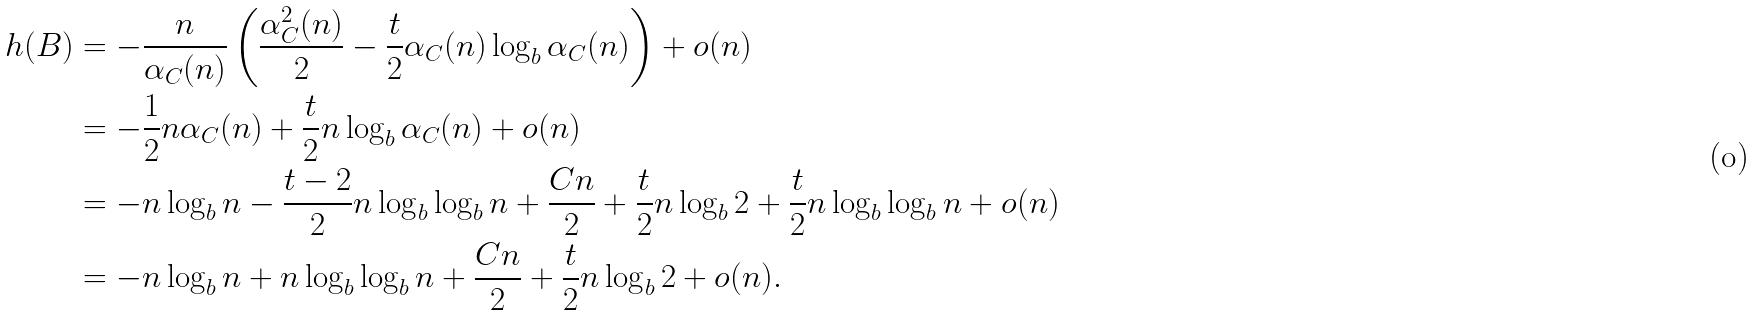<formula> <loc_0><loc_0><loc_500><loc_500>h ( B ) & = - \frac { n } { \alpha _ { C } ( n ) } \left ( \frac { \alpha _ { C } ^ { 2 } ( n ) } { 2 } - \frac { t } { 2 } \alpha _ { C } ( n ) \log _ { b } \alpha _ { C } ( n ) \right ) + o ( n ) \\ & = - \frac { 1 } { 2 } n \alpha _ { C } ( n ) + \frac { t } { 2 } n \log _ { b } \alpha _ { C } ( n ) + o ( n ) \\ & = - n \log _ { b } n - \frac { t - 2 } { 2 } n \log _ { b } \log _ { b } n + \frac { C n } { 2 } + \frac { t } { 2 } n \log _ { b } 2 + \frac { t } { 2 } n \log _ { b } \log _ { b } n + o ( n ) \\ & = - n \log _ { b } n + n \log _ { b } \log _ { b } n + \frac { C n } { 2 } + \frac { t } { 2 } n \log _ { b } 2 + o ( n ) .</formula> 